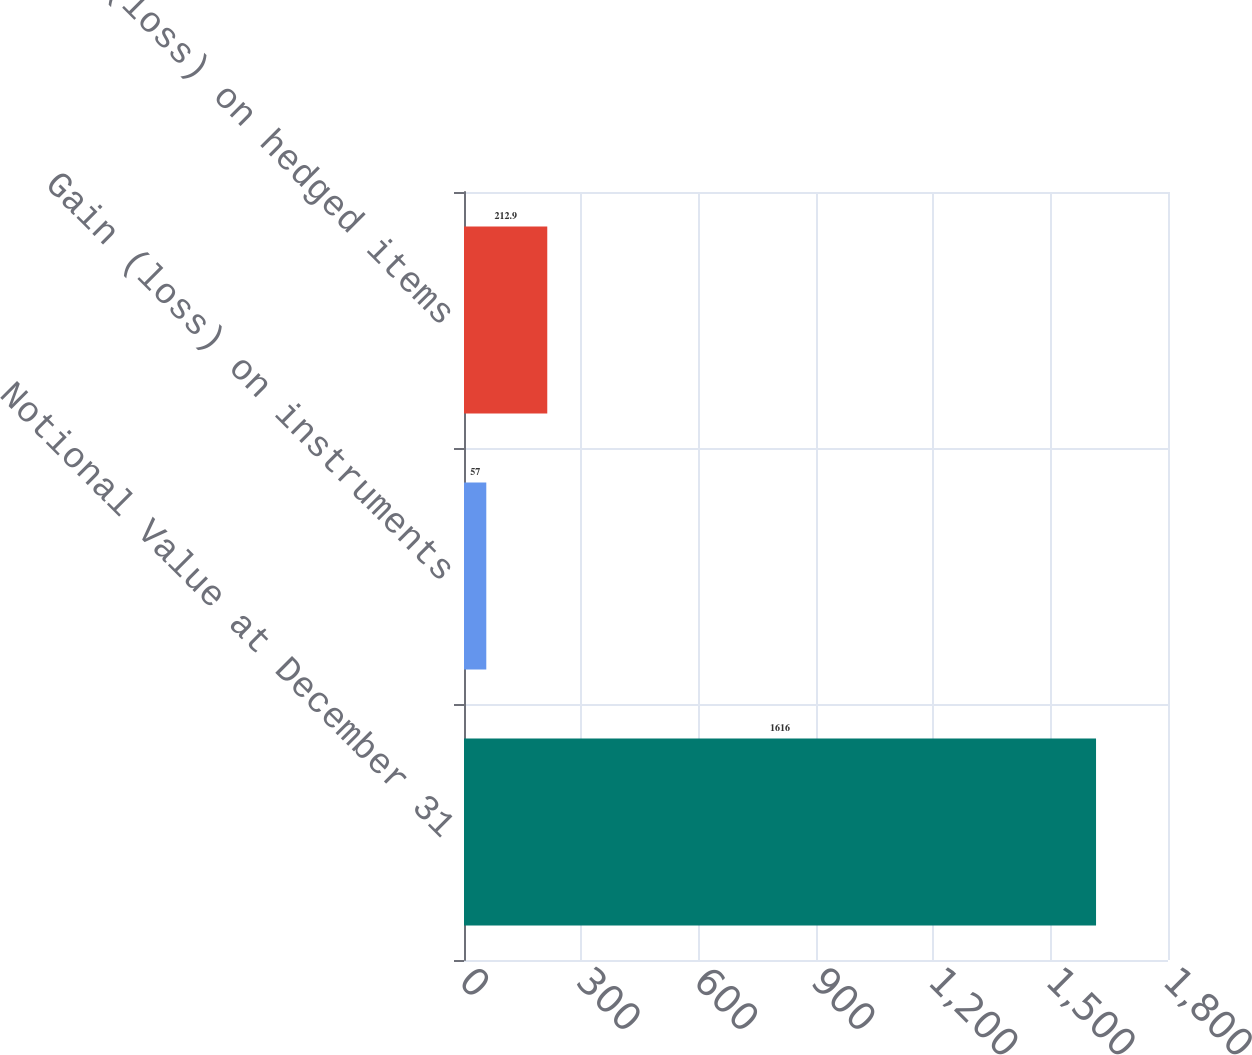<chart> <loc_0><loc_0><loc_500><loc_500><bar_chart><fcel>Notional Value at December 31<fcel>Gain (loss) on instruments<fcel>Gain (loss) on hedged items<nl><fcel>1616<fcel>57<fcel>212.9<nl></chart> 